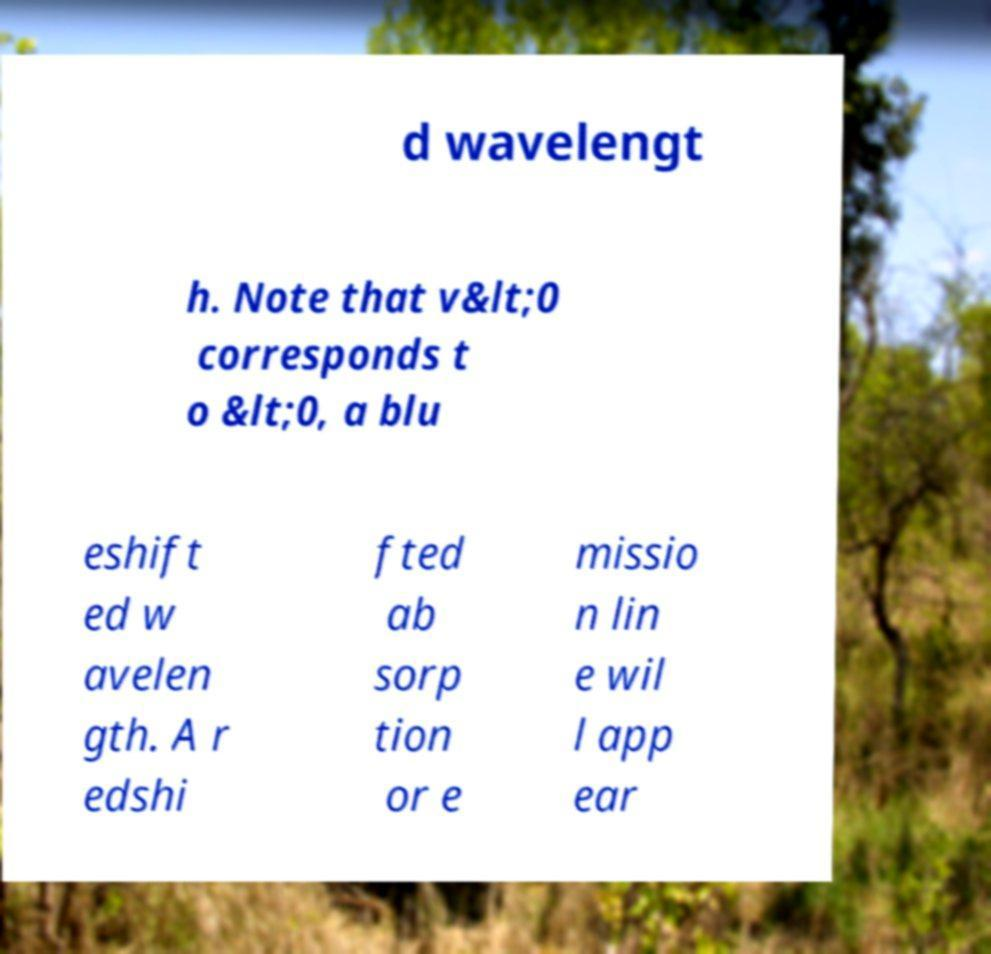Please read and relay the text visible in this image. What does it say? d wavelengt h. Note that v&lt;0 corresponds t o &lt;0, a blu eshift ed w avelen gth. A r edshi fted ab sorp tion or e missio n lin e wil l app ear 